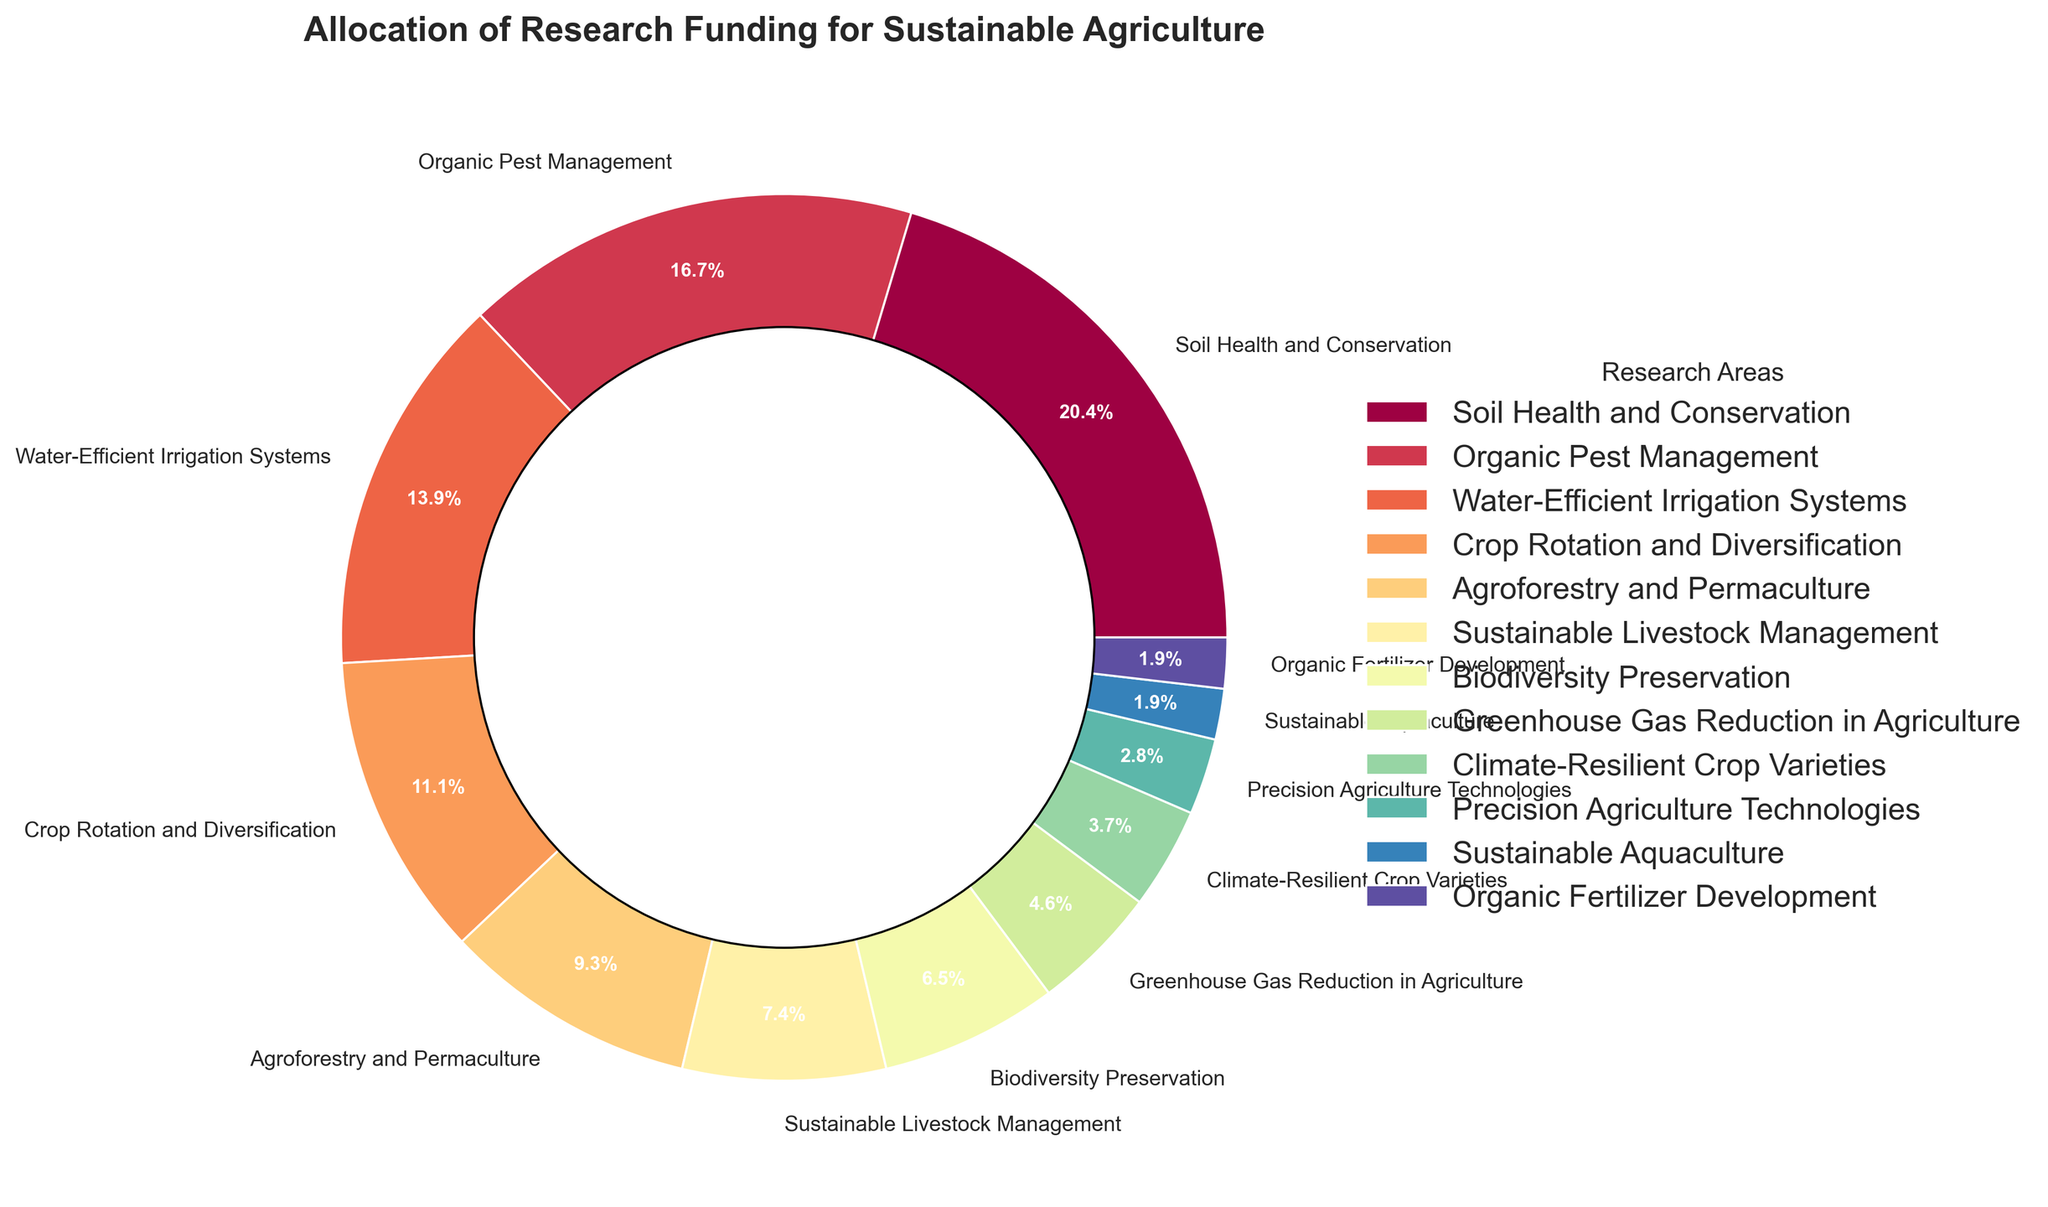What's the largest area of research funding? The largest segment in the pie chart has the highest percentage. The "Soil Health and Conservation" category has the largest slice, shown as 22%.
Answer: Soil Health and Conservation Which research areas are funded less than 10%? Look for the segments with a percentage smaller than 10%. The areas are "Sustainable Livestock Management," "Biodiversity Preservation," "Greenhouse Gas Reduction in Agriculture," "Climate-Resilient Crop Varieties," "Precision Agriculture Technologies," "Sustainable Aquaculture," and "Organic Fertilizer Development."
Answer: Sustainable Livestock Management, Biodiversity Preservation, Greenhouse Gas Reduction in Agriculture, Climate-Resilient Crop Varieties, Precision Agriculture Technologies, Sustainable Aquaculture, Organic Fertilizer Development What is the total funding percentage for water-related initiatives? Identify the water-related initiatives and sum their percentages. The relevant categories are "Water-Efficient Irrigation Systems" (15%) and "Sustainable Aquaculture" (2%). Summing these gives 15% + 2% = 17%.
Answer: 17% What is the difference in funding percentage between "Organic Pest Management" and "Crop Rotation and Diversification"? Subtract the funding percentage of "Crop Rotation and Diversification" (12%) from "Organic Pest Management" (18%). This gives 18% - 12% = 6%.
Answer: 6% Are there any research areas with equal funding percentages? Check all segments to see if any of them have the same percentage. "Sustainable Aquaculture" and "Organic Fertilizer Development" both have 2%.
Answer: Yes How much more funding does "Organic Pest Management" receive compared to "Biodiversity Preservation"? Subtract the funding percentage of "Biodiversity Preservation" (7%) from "Organic Pest Management" (18%). This gives 18% - 7% = 11%.
Answer: 11% What visual color is used for "Soil Health and Conservation"? Identify the color of the segment for "Soil Health and Conservation". It shows a specific shade based on the color palette used for the plot. The color should be interpreted based on visual inspection.
Answer: (According to frame of reference - Specify the observed color, such as "bright yellow" or similar.) Which two research areas combined have approximately one-third of the total funding? Look for two segments whose combined percentage is close to 33%. "Soil Health and Conservation" (22%) and "Organic Pest Management" (18%) combined give 22% + 18% = 40%, which is close to a third.
Answer: Soil Health and Conservation, Organic Pest Management What is the total funding percentage for initiatives directly involving plant crops (excluding livestock and aquaculture)? Sum the percentages of relevant categories: "Soil Health and Conservation" (22%), "Organic Pest Management" (18%), "Water-Efficient Irrigation Systems" (15%), "Crop Rotation and Diversification" (12%), and "Agroforestry and Permaculture" (10%). Total is 22% + 18% + 15% + 12% + 10% = 77%.
Answer: 77% If funding for "Greenhouse Gas Reduction in Agriculture" were doubled, what would be its new percentage? Given that the current percentage is 5%, doubling it would be 5% * 2 = 10%.
Answer: 10% 